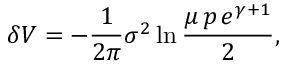<formula> <loc_0><loc_0><loc_500><loc_500>\delta V = - \frac { 1 } { 2 \pi } \sigma ^ { 2 } \ln \frac { \mu \, p \, e ^ { \gamma + 1 } } { 2 } ,</formula> 